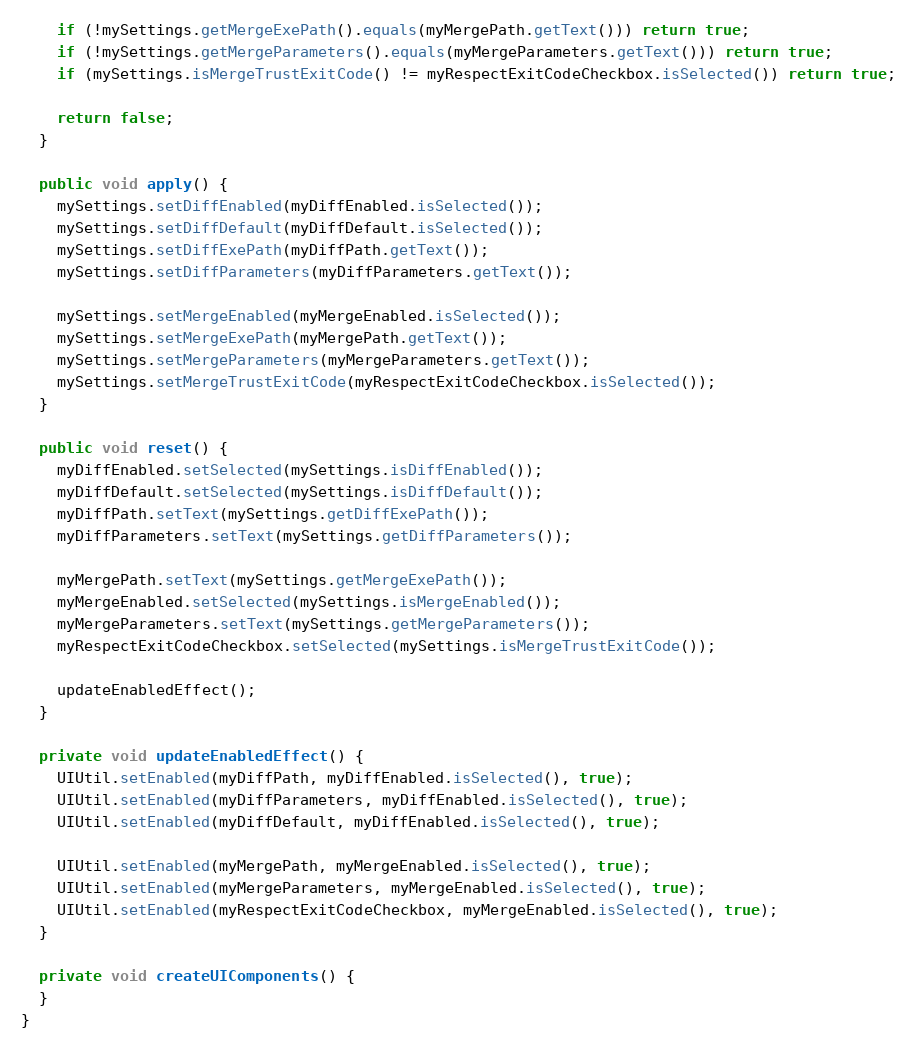<code> <loc_0><loc_0><loc_500><loc_500><_Java_>    if (!mySettings.getMergeExePath().equals(myMergePath.getText())) return true;
    if (!mySettings.getMergeParameters().equals(myMergeParameters.getText())) return true;
    if (mySettings.isMergeTrustExitCode() != myRespectExitCodeCheckbox.isSelected()) return true;

    return false;
  }

  public void apply() {
    mySettings.setDiffEnabled(myDiffEnabled.isSelected());
    mySettings.setDiffDefault(myDiffDefault.isSelected());
    mySettings.setDiffExePath(myDiffPath.getText());
    mySettings.setDiffParameters(myDiffParameters.getText());

    mySettings.setMergeEnabled(myMergeEnabled.isSelected());
    mySettings.setMergeExePath(myMergePath.getText());
    mySettings.setMergeParameters(myMergeParameters.getText());
    mySettings.setMergeTrustExitCode(myRespectExitCodeCheckbox.isSelected());
  }

  public void reset() {
    myDiffEnabled.setSelected(mySettings.isDiffEnabled());
    myDiffDefault.setSelected(mySettings.isDiffDefault());
    myDiffPath.setText(mySettings.getDiffExePath());
    myDiffParameters.setText(mySettings.getDiffParameters());

    myMergePath.setText(mySettings.getMergeExePath());
    myMergeEnabled.setSelected(mySettings.isMergeEnabled());
    myMergeParameters.setText(mySettings.getMergeParameters());
    myRespectExitCodeCheckbox.setSelected(mySettings.isMergeTrustExitCode());

    updateEnabledEffect();
  }

  private void updateEnabledEffect() {
    UIUtil.setEnabled(myDiffPath, myDiffEnabled.isSelected(), true);
    UIUtil.setEnabled(myDiffParameters, myDiffEnabled.isSelected(), true);
    UIUtil.setEnabled(myDiffDefault, myDiffEnabled.isSelected(), true);

    UIUtil.setEnabled(myMergePath, myMergeEnabled.isSelected(), true);
    UIUtil.setEnabled(myMergeParameters, myMergeEnabled.isSelected(), true);
    UIUtil.setEnabled(myRespectExitCodeCheckbox, myMergeEnabled.isSelected(), true);
  }

  private void createUIComponents() {
  }
}
</code> 